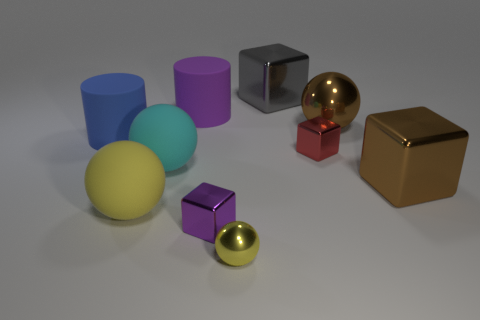Are there fewer large brown shiny things than large shiny objects?
Keep it short and to the point. Yes. What shape is the large thing that is left of the brown cube and right of the tiny red metallic object?
Make the answer very short. Sphere. How many brown objects are there?
Make the answer very short. 2. What is the material of the tiny object that is to the right of the metallic sphere that is to the left of the tiny shiny thing to the right of the gray shiny thing?
Provide a short and direct response. Metal. There is a large brown metallic thing in front of the big brown ball; what number of metallic spheres are behind it?
Give a very brief answer. 1. What is the color of the big metal object that is the same shape as the tiny yellow thing?
Offer a very short reply. Brown. Is the purple cylinder made of the same material as the big cyan thing?
Provide a short and direct response. Yes. What number of spheres are either big purple rubber objects or large cyan objects?
Your answer should be very brief. 1. There is a cylinder to the left of the purple thing behind the metal ball to the right of the red metal cube; what is its size?
Your answer should be compact. Large. What is the size of the brown metallic thing that is the same shape as the big gray object?
Make the answer very short. Large. 